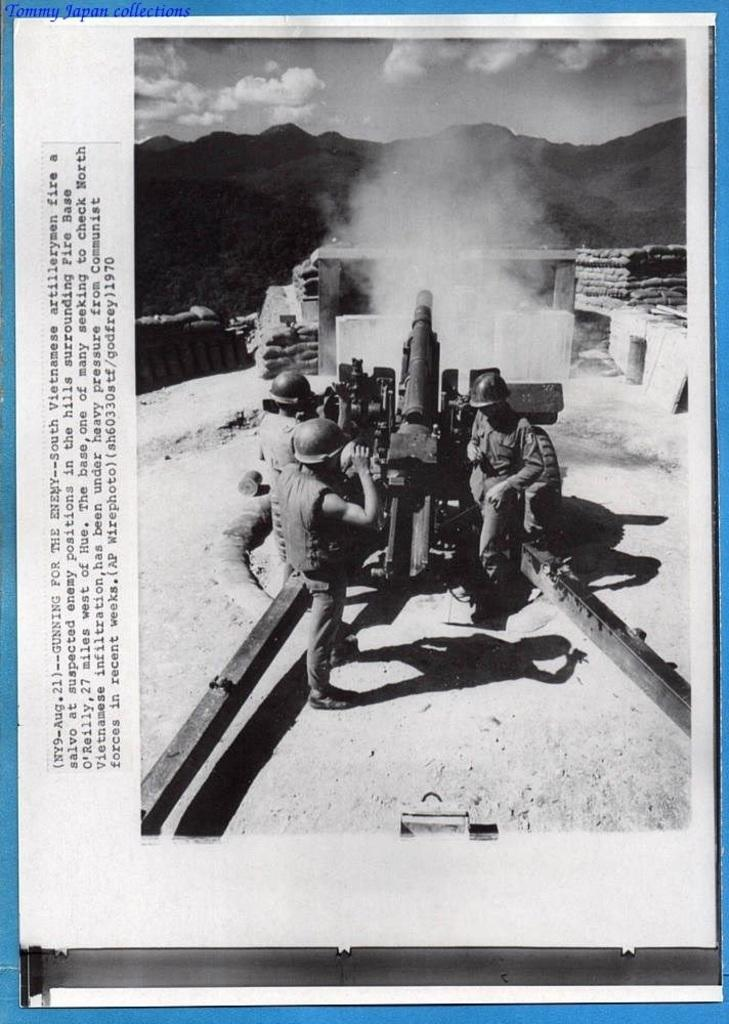Who or what can be seen in the image? There are people in the image. What are the people doing or standing near in the image? The people are standing near a war weapon in the image. What is the color scheme of the image? The image is in black and white color. What type of acoustics can be heard coming from the war weapon in the image? There is no indication of sound or acoustics in the image, as it is a still photograph. 